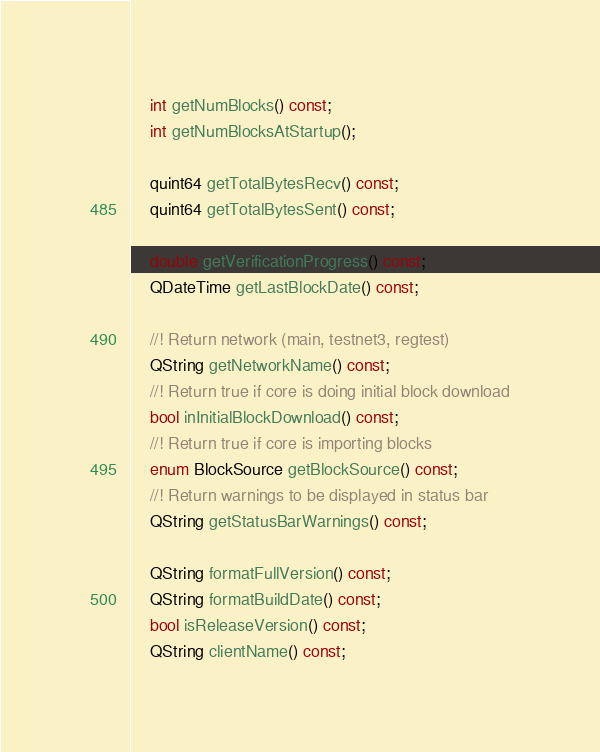<code> <loc_0><loc_0><loc_500><loc_500><_C_>    int getNumBlocks() const;
    int getNumBlocksAtStartup();

    quint64 getTotalBytesRecv() const;
    quint64 getTotalBytesSent() const;

    double getVerificationProgress() const;
    QDateTime getLastBlockDate() const;

    //! Return network (main, testnet3, regtest)
    QString getNetworkName() const;
    //! Return true if core is doing initial block download
    bool inInitialBlockDownload() const;
    //! Return true if core is importing blocks
    enum BlockSource getBlockSource() const;
    //! Return warnings to be displayed in status bar
    QString getStatusBarWarnings() const;

    QString formatFullVersion() const;
    QString formatBuildDate() const;
    bool isReleaseVersion() const;
    QString clientName() const;</code> 